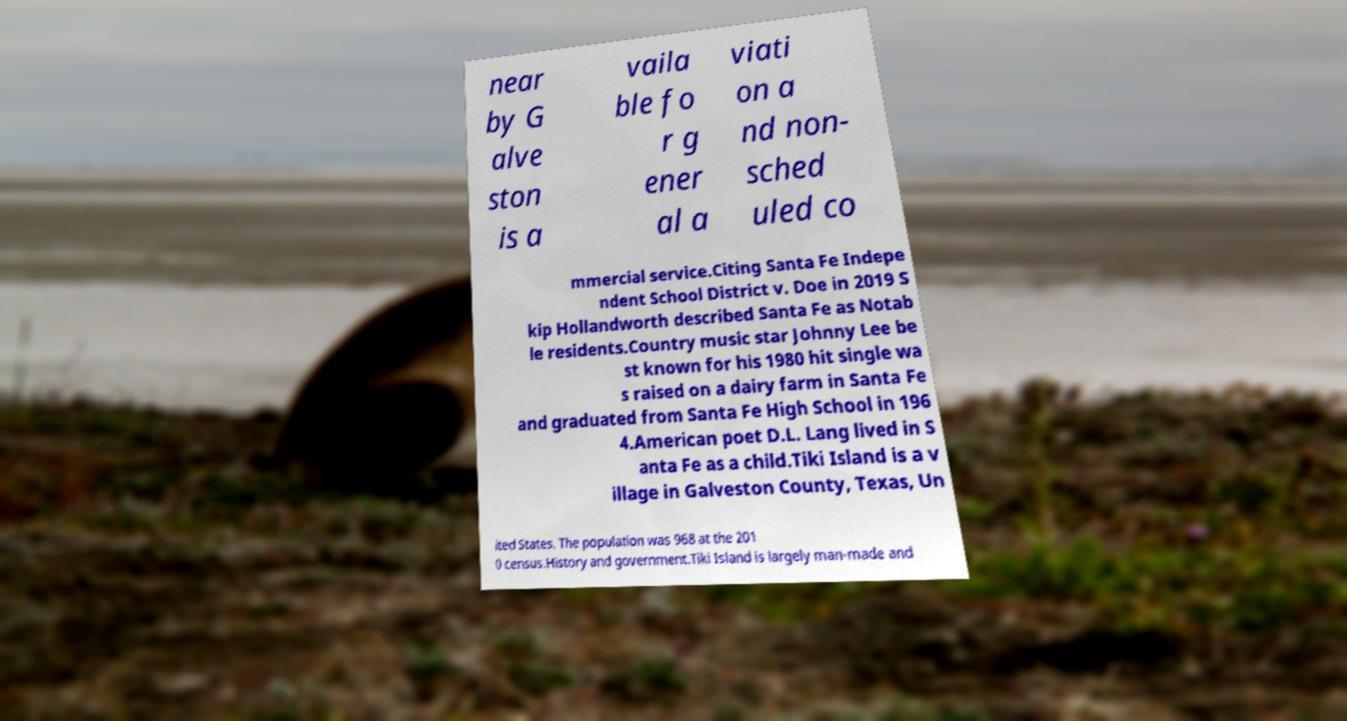Please identify and transcribe the text found in this image. near by G alve ston is a vaila ble fo r g ener al a viati on a nd non- sched uled co mmercial service.Citing Santa Fe Indepe ndent School District v. Doe in 2019 S kip Hollandworth described Santa Fe as Notab le residents.Country music star Johnny Lee be st known for his 1980 hit single wa s raised on a dairy farm in Santa Fe and graduated from Santa Fe High School in 196 4.American poet D.L. Lang lived in S anta Fe as a child.Tiki Island is a v illage in Galveston County, Texas, Un ited States. The population was 968 at the 201 0 census.History and government.Tiki Island is largely man-made and 